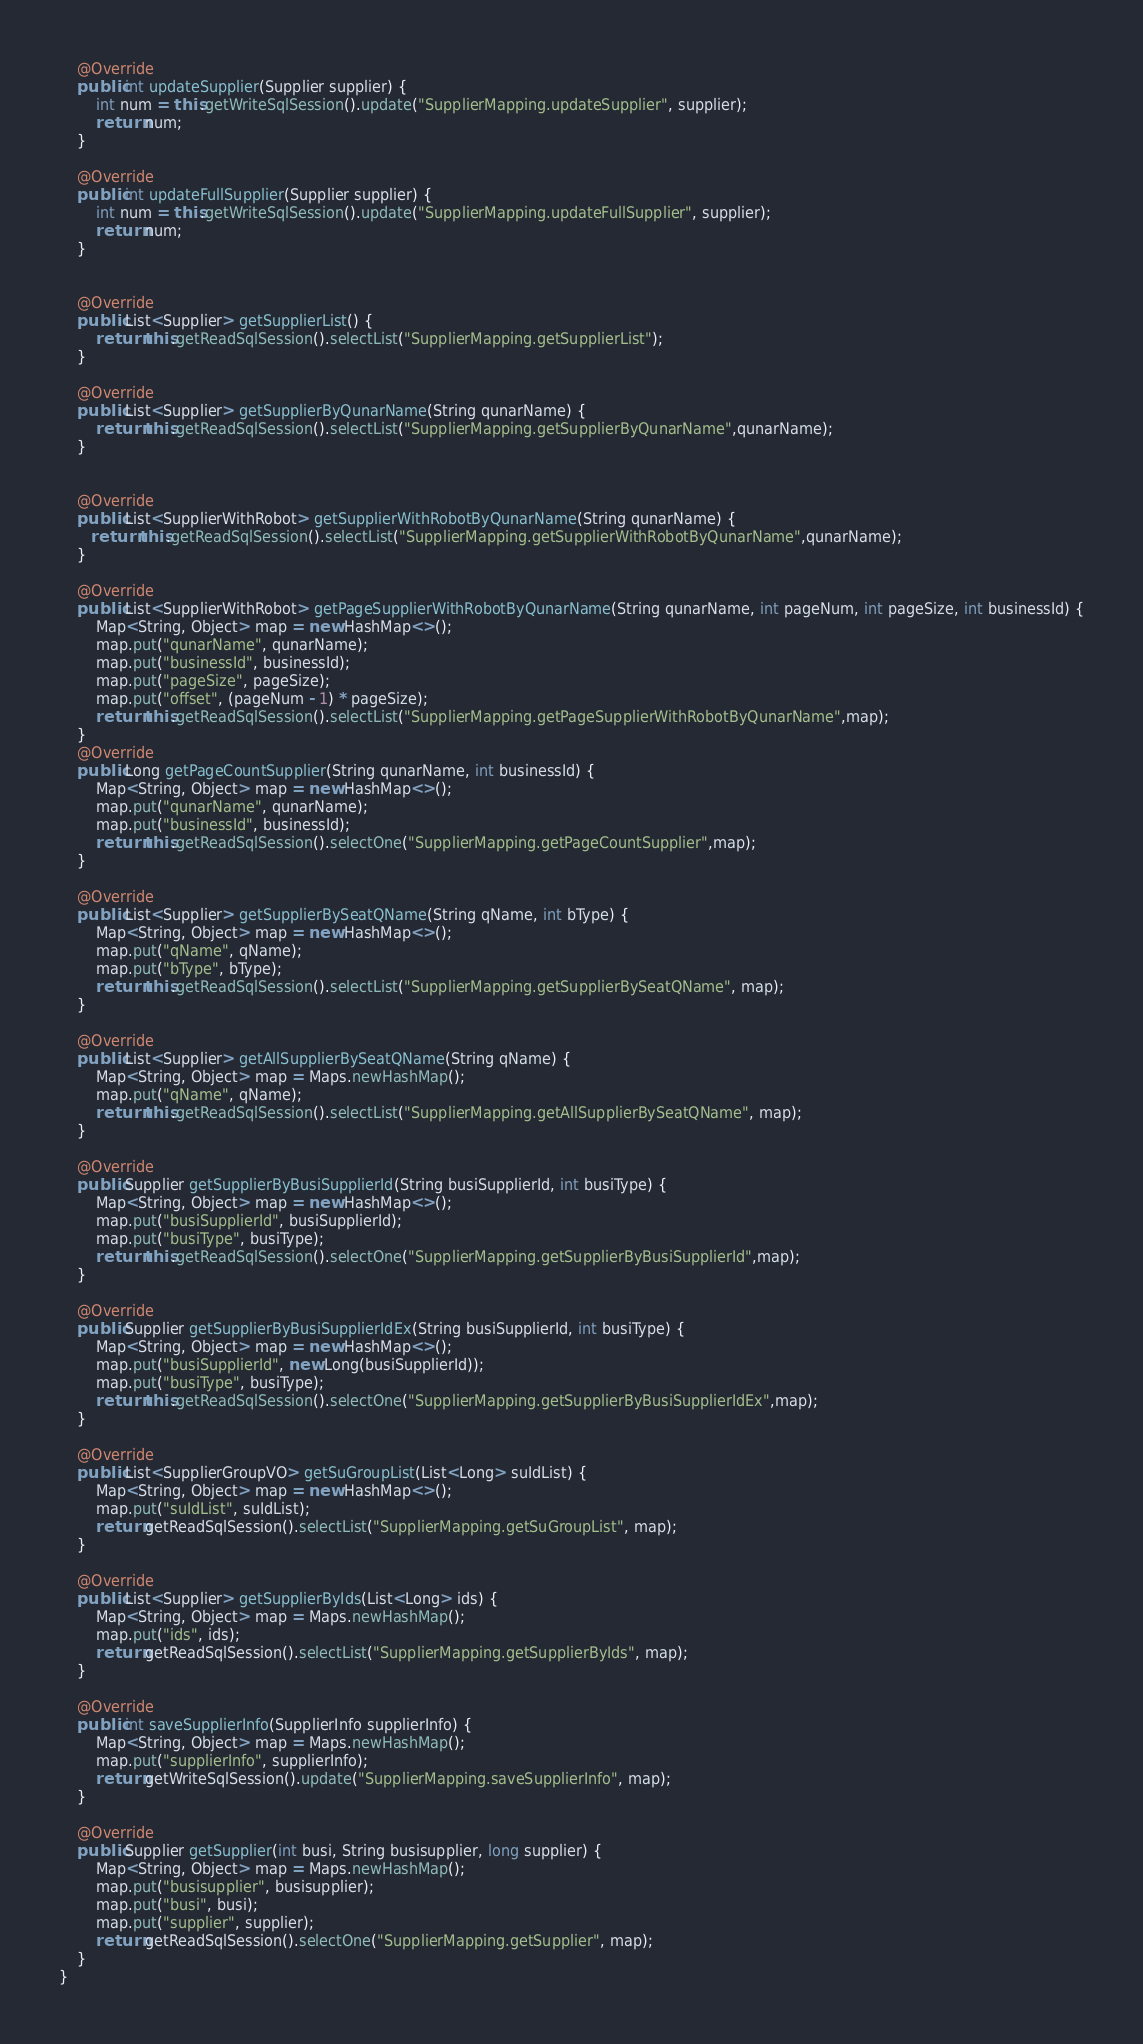<code> <loc_0><loc_0><loc_500><loc_500><_Java_>
    @Override
    public int updateSupplier(Supplier supplier) {
        int num = this.getWriteSqlSession().update("SupplierMapping.updateSupplier", supplier);
        return num;
    }

    @Override
    public int updateFullSupplier(Supplier supplier) {
        int num = this.getWriteSqlSession().update("SupplierMapping.updateFullSupplier", supplier);
        return num;
    }


    @Override
    public List<Supplier> getSupplierList() {
        return this.getReadSqlSession().selectList("SupplierMapping.getSupplierList");
    }

    @Override
    public List<Supplier> getSupplierByQunarName(String qunarName) {
        return this.getReadSqlSession().selectList("SupplierMapping.getSupplierByQunarName",qunarName);
    }


    @Override
    public List<SupplierWithRobot> getSupplierWithRobotByQunarName(String qunarName) {
       return this.getReadSqlSession().selectList("SupplierMapping.getSupplierWithRobotByQunarName",qunarName);
    }

    @Override
    public List<SupplierWithRobot> getPageSupplierWithRobotByQunarName(String qunarName, int pageNum, int pageSize, int businessId) {
        Map<String, Object> map = new HashMap<>();
        map.put("qunarName", qunarName);
        map.put("businessId", businessId);
        map.put("pageSize", pageSize);
        map.put("offset", (pageNum - 1) * pageSize);
        return this.getReadSqlSession().selectList("SupplierMapping.getPageSupplierWithRobotByQunarName",map);
    }
    @Override
    public Long getPageCountSupplier(String qunarName, int businessId) {
        Map<String, Object> map = new HashMap<>();
        map.put("qunarName", qunarName);
        map.put("businessId", businessId);
        return this.getReadSqlSession().selectOne("SupplierMapping.getPageCountSupplier",map);
    }

    @Override
    public List<Supplier> getSupplierBySeatQName(String qName, int bType) {
        Map<String, Object> map = new HashMap<>();
        map.put("qName", qName);
        map.put("bType", bType);
        return this.getReadSqlSession().selectList("SupplierMapping.getSupplierBySeatQName", map);
    }

    @Override
    public List<Supplier> getAllSupplierBySeatQName(String qName) {
        Map<String, Object> map = Maps.newHashMap();
        map.put("qName", qName);
        return this.getReadSqlSession().selectList("SupplierMapping.getAllSupplierBySeatQName", map);
    }

    @Override
    public Supplier getSupplierByBusiSupplierId(String busiSupplierId, int busiType) {
        Map<String, Object> map = new HashMap<>();
        map.put("busiSupplierId", busiSupplierId);
        map.put("busiType", busiType);
        return this.getReadSqlSession().selectOne("SupplierMapping.getSupplierByBusiSupplierId",map);
    }

    @Override
    public Supplier getSupplierByBusiSupplierIdEx(String busiSupplierId, int busiType) {
        Map<String, Object> map = new HashMap<>();
        map.put("busiSupplierId", new Long(busiSupplierId));
        map.put("busiType", busiType);
        return this.getReadSqlSession().selectOne("SupplierMapping.getSupplierByBusiSupplierIdEx",map);
    }

    @Override
    public List<SupplierGroupVO> getSuGroupList(List<Long> suIdList) {
        Map<String, Object> map = new HashMap<>();
        map.put("suIdList", suIdList);
        return getReadSqlSession().selectList("SupplierMapping.getSuGroupList", map);
    }

    @Override
    public List<Supplier> getSupplierByIds(List<Long> ids) {
        Map<String, Object> map = Maps.newHashMap();
        map.put("ids", ids);
        return getReadSqlSession().selectList("SupplierMapping.getSupplierByIds", map);
    }

    @Override
    public int saveSupplierInfo(SupplierInfo supplierInfo) {
        Map<String, Object> map = Maps.newHashMap();
        map.put("supplierInfo", supplierInfo);
        return getWriteSqlSession().update("SupplierMapping.saveSupplierInfo", map);
    }

    @Override
    public Supplier getSupplier(int busi, String busisupplier, long supplier) {
        Map<String, Object> map = Maps.newHashMap();
        map.put("busisupplier", busisupplier);
        map.put("busi", busi);
        map.put("supplier", supplier);
        return getReadSqlSession().selectOne("SupplierMapping.getSupplier", map);
    }
}
</code> 